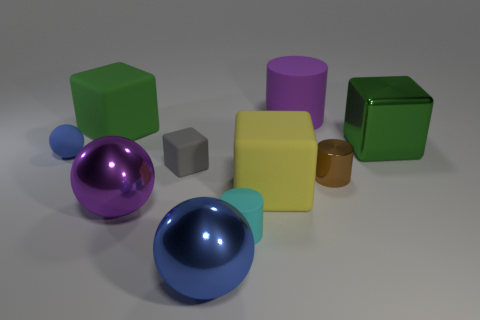What number of yellow things are either large cylinders or tiny rubber objects?
Make the answer very short. 0. What size is the blue ball that is made of the same material as the tiny cube?
Your response must be concise. Small. How many green matte things have the same shape as the gray object?
Your answer should be compact. 1. Are there more rubber spheres that are in front of the large purple matte object than small cyan cylinders that are behind the large purple ball?
Provide a succinct answer. Yes. Do the tiny matte ball and the big thing in front of the tiny rubber cylinder have the same color?
Give a very brief answer. Yes. There is a cylinder that is the same size as the cyan rubber object; what is its material?
Your response must be concise. Metal. How many objects are either green rubber things or large metal spheres that are behind the blue metallic thing?
Your response must be concise. 2. Does the metallic block have the same size as the blue thing that is in front of the large purple sphere?
Provide a succinct answer. Yes. What number of cylinders are either yellow objects or blue shiny objects?
Your answer should be very brief. 0. What number of blocks are left of the yellow cube and right of the green matte block?
Make the answer very short. 1. 